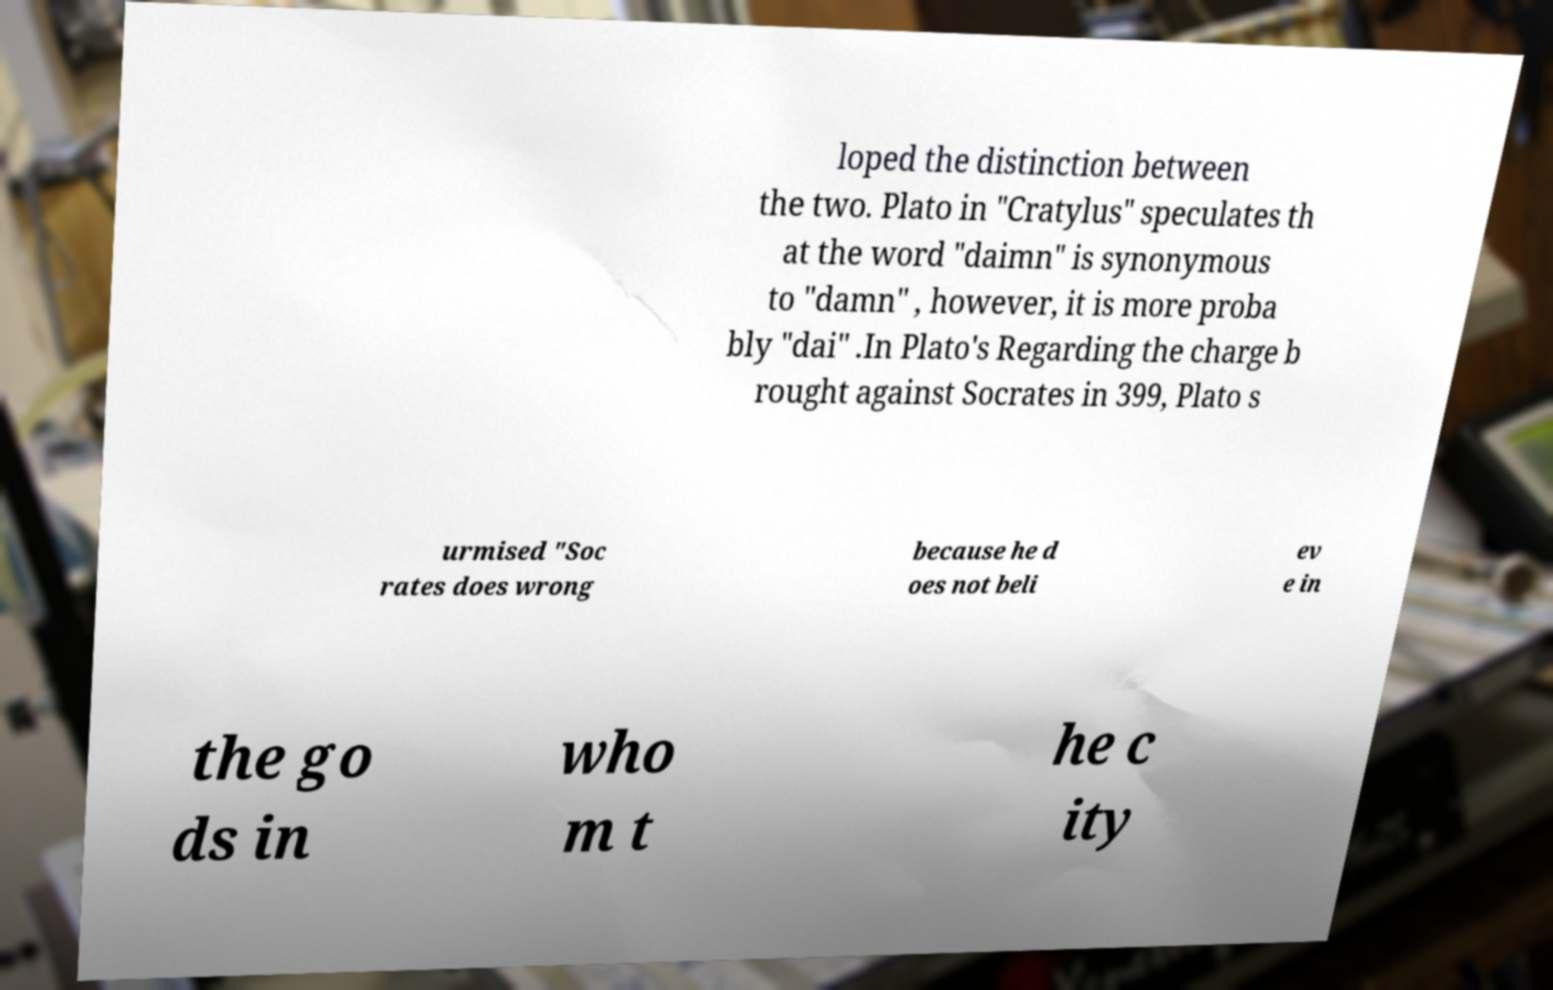Please identify and transcribe the text found in this image. loped the distinction between the two. Plato in "Cratylus" speculates th at the word "daimn" is synonymous to "damn" , however, it is more proba bly "dai" .In Plato's Regarding the charge b rought against Socrates in 399, Plato s urmised "Soc rates does wrong because he d oes not beli ev e in the go ds in who m t he c ity 